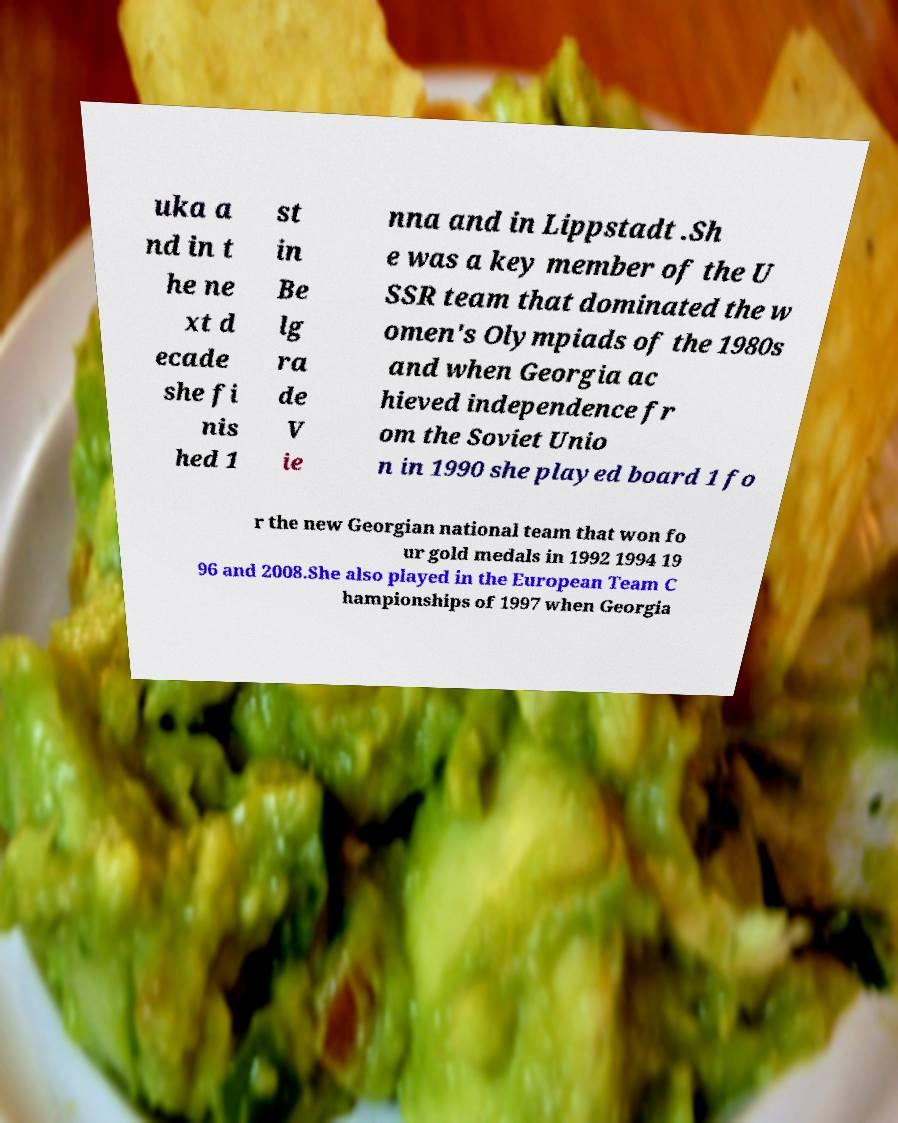Can you read and provide the text displayed in the image?This photo seems to have some interesting text. Can you extract and type it out for me? uka a nd in t he ne xt d ecade she fi nis hed 1 st in Be lg ra de V ie nna and in Lippstadt .Sh e was a key member of the U SSR team that dominated the w omen's Olympiads of the 1980s and when Georgia ac hieved independence fr om the Soviet Unio n in 1990 she played board 1 fo r the new Georgian national team that won fo ur gold medals in 1992 1994 19 96 and 2008.She also played in the European Team C hampionships of 1997 when Georgia 